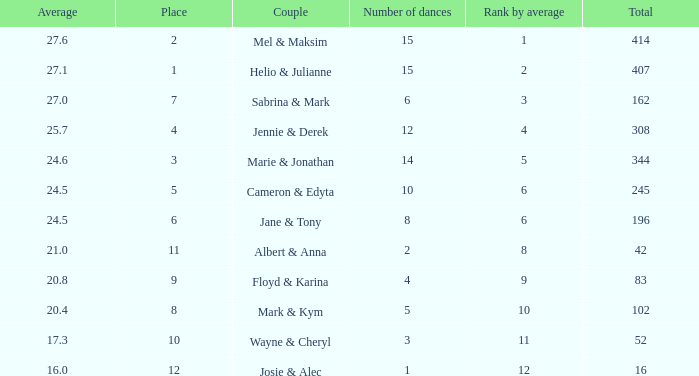What is the rank by average where the total was larger than 245 and the average was 27.1 with fewer than 15 dances? None. 